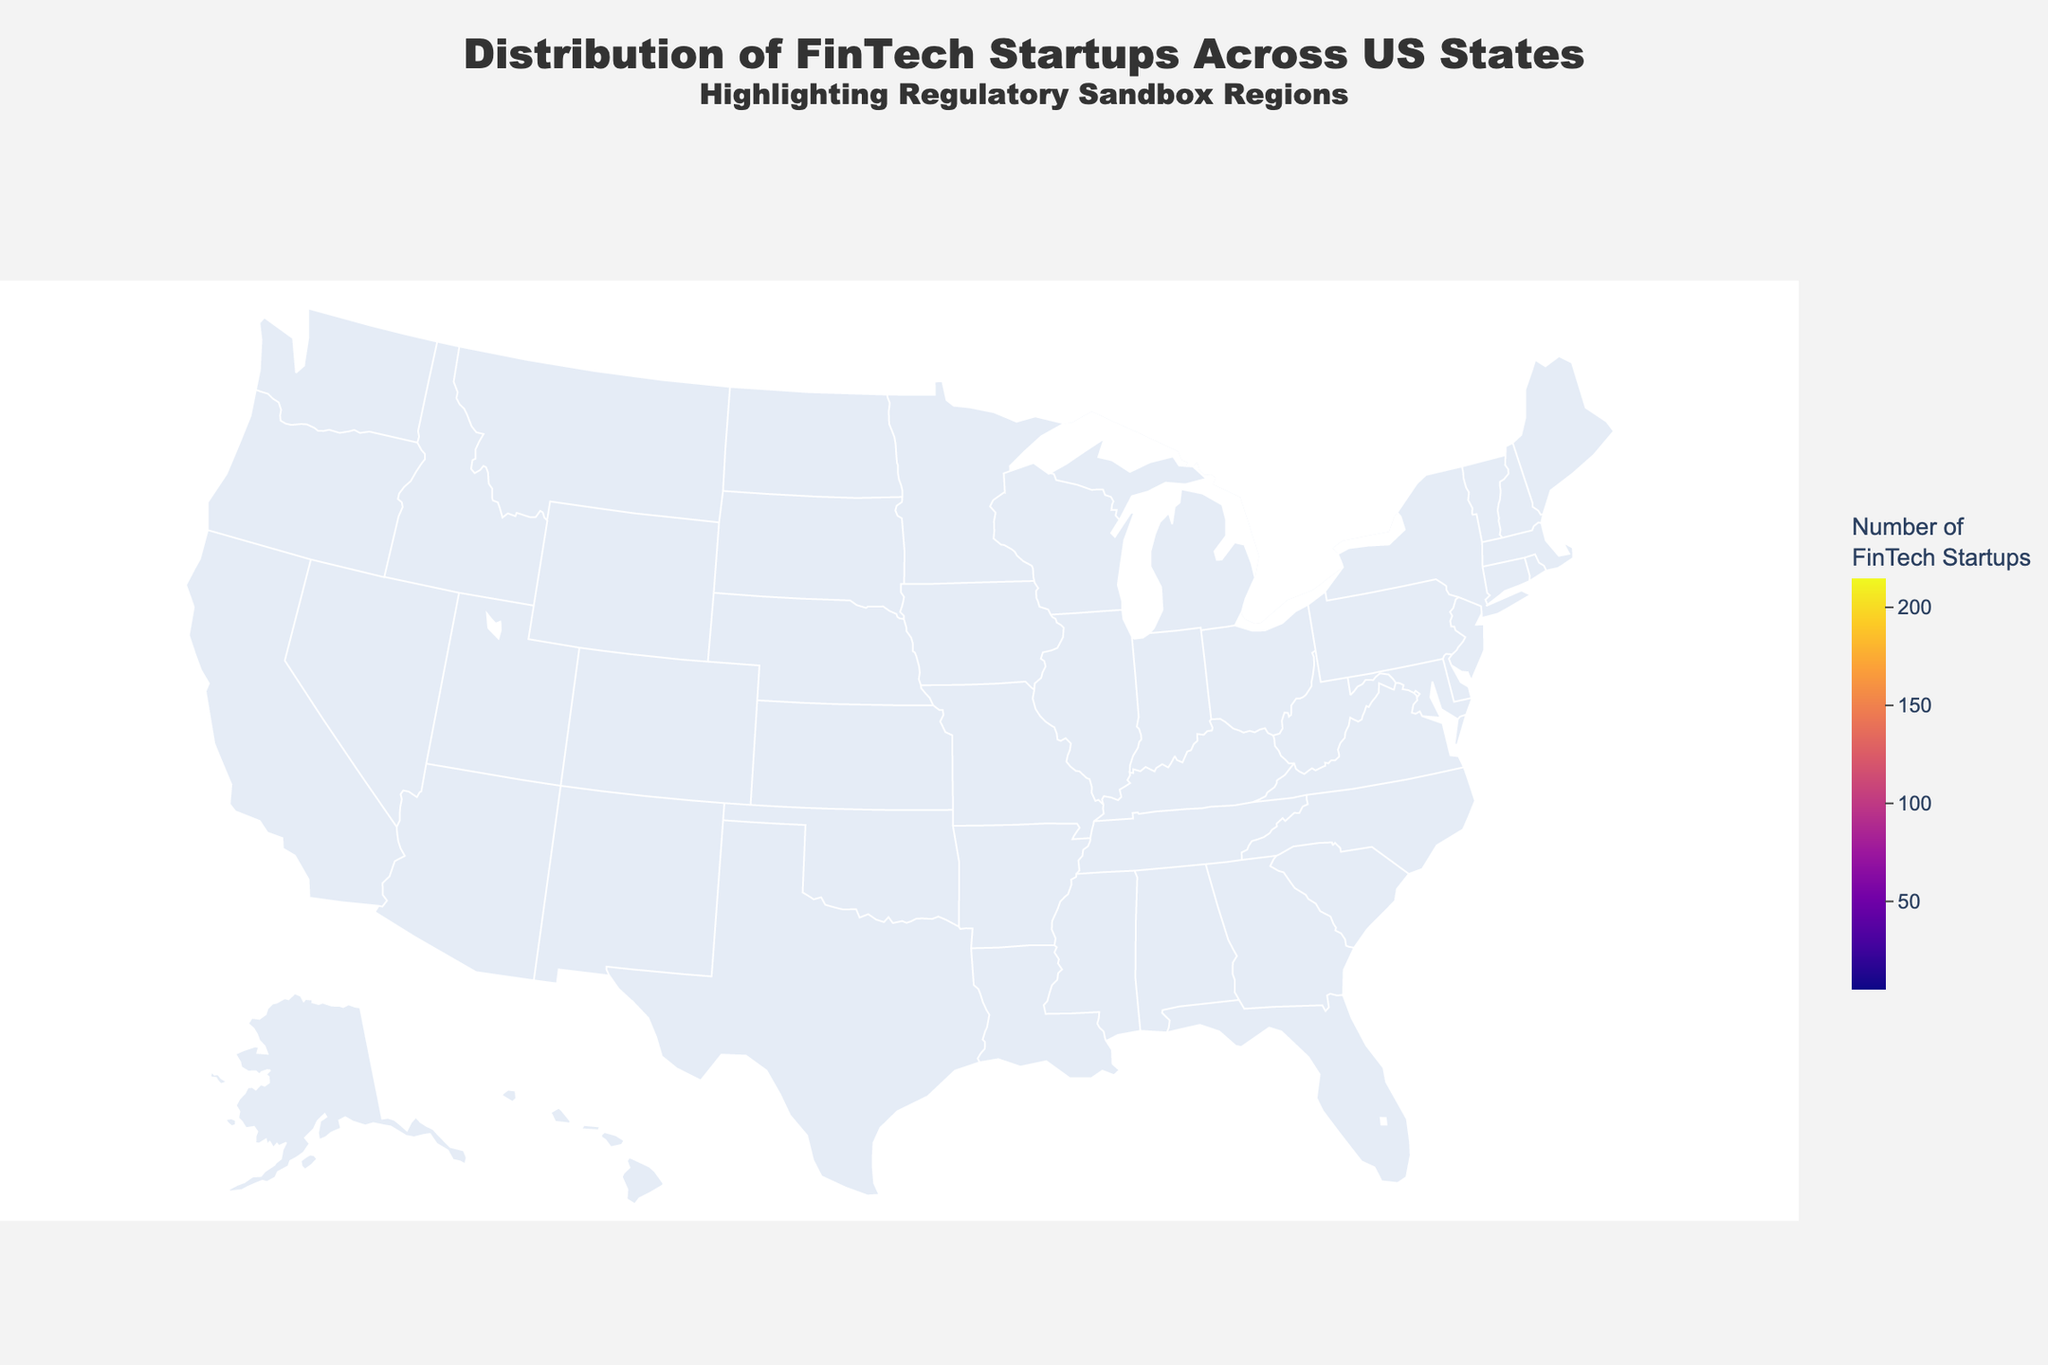Which state has the highest number of FinTech startups? To find the state with the highest number of FinTech startups, look for the state with the largest value in the "FinTech Startups" color scale. California has the highest count.
Answer: California Which states have regulatory sandboxes? Regulatory sandbox states are marked by lime-colored stars. The states with these markers are Texas, Arizona, Utah, Colorado, Nevada, Wyoming, Kentucky, Hawaii, and West Virginia.
Answer: Texas, Arizona, Utah, Colorado, Nevada, Wyoming, Kentucky, Hawaii, West Virginia How many FinTech startups are there in states with regulatory sandboxes? Sum the number of FinTech startups for states with lime-colored stars: Texas (75), Arizona (50), Utah (45), Colorado (40), Nevada (15), Wyoming (12), Kentucky (10), Hawaii (8), West Virginia (5). 75 + 50 + 45 + 40 + 15 + 12 + 10 + 8 + 5 = 260.
Answer: 260 Which state in the regulatory sandbox category has the most FinTech startups? Identify the states marked by lime-colored stars and compare their FinTech startup numbers. Texas has the most with 75 startups.
Answer: Texas How does the number of FinTech startups in Arizona compare to Colorado? Look at the values for Arizona and Colorado. Arizona has 50 startups and Colorado has 40. Arizona has 10 more startups than Colorado.
Answer: Arizona has 10 more What is the total number of FinTech startups in California and New York combined? Add the number of startups in California (215) and New York (180). 215 + 180 = 395.
Answer: 395 Is the number of FinTech startups in Massachusetts greater than in Illinois and Georgia combined? Compare Massachusetts (95) with Illinois (55) and Georgia (35) combined. 55 + 35 = 90. 95 > 90, hence Massachusetts has more.
Answer: Yes Which state has the fewest FinTech startups? Find the state with the smallest number in the "FinTech Startups" scale. West Virginia has the fewest with 5 startups.
Answer: West Virginia How many states have more than 50 FinTech startups? Count the states with startup counts higher than 50. California, New York, Massachusetts, Texas, Florida, Illinois, and Arizona meet this criterion. There are 7 states.
Answer: 7 Are there more FinTech startups in regulatory sandbox states compared to non-regulatory sandbox states? Sum startups in regulatory sandbox states (260 from a previous answer) and non-sandbox states: California (215), New York (180), Massachusetts (95), Florida (60), Illinois (55), Georgia (35), Washington (30), North Carolina (25), New Jersey (20), Pennsylvania (18). Total non-sandbox: 733. 260 < 733, meaning non-sandbox states have more.
Answer: No 